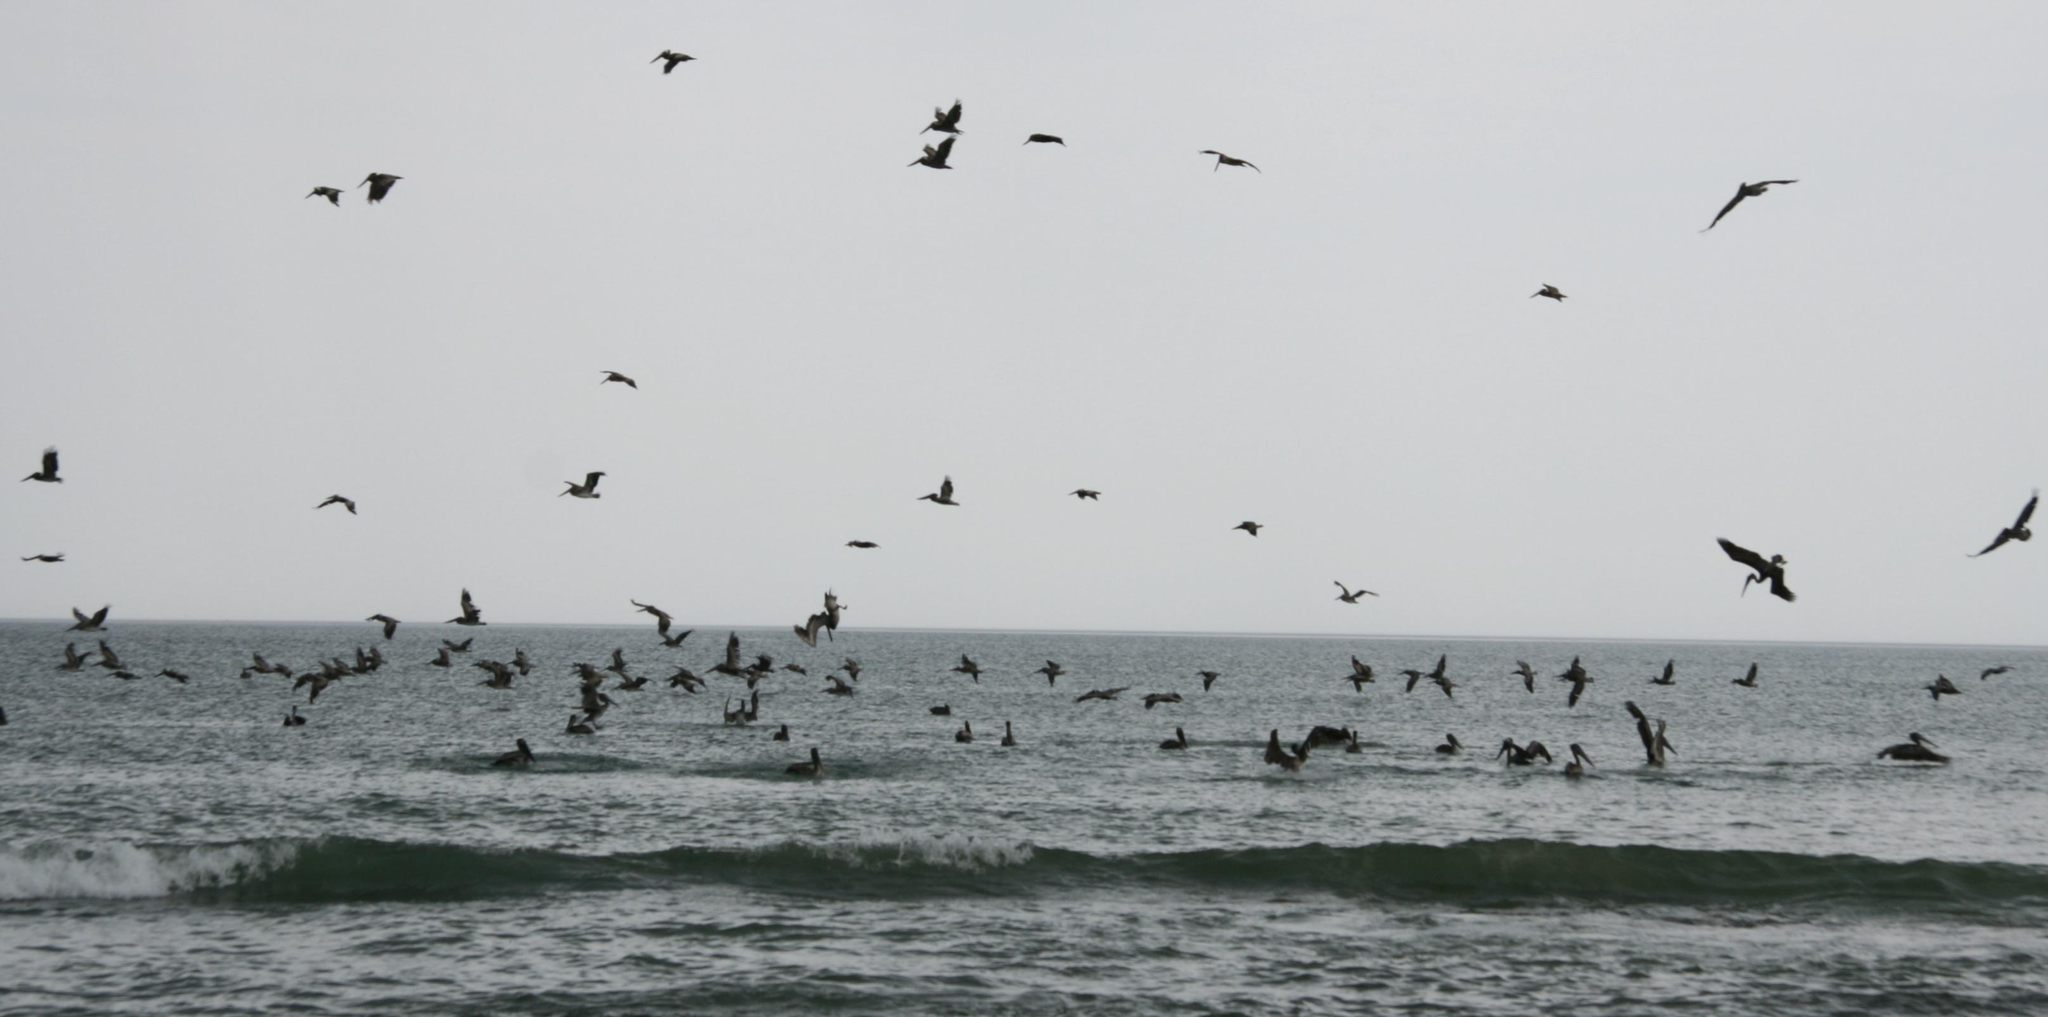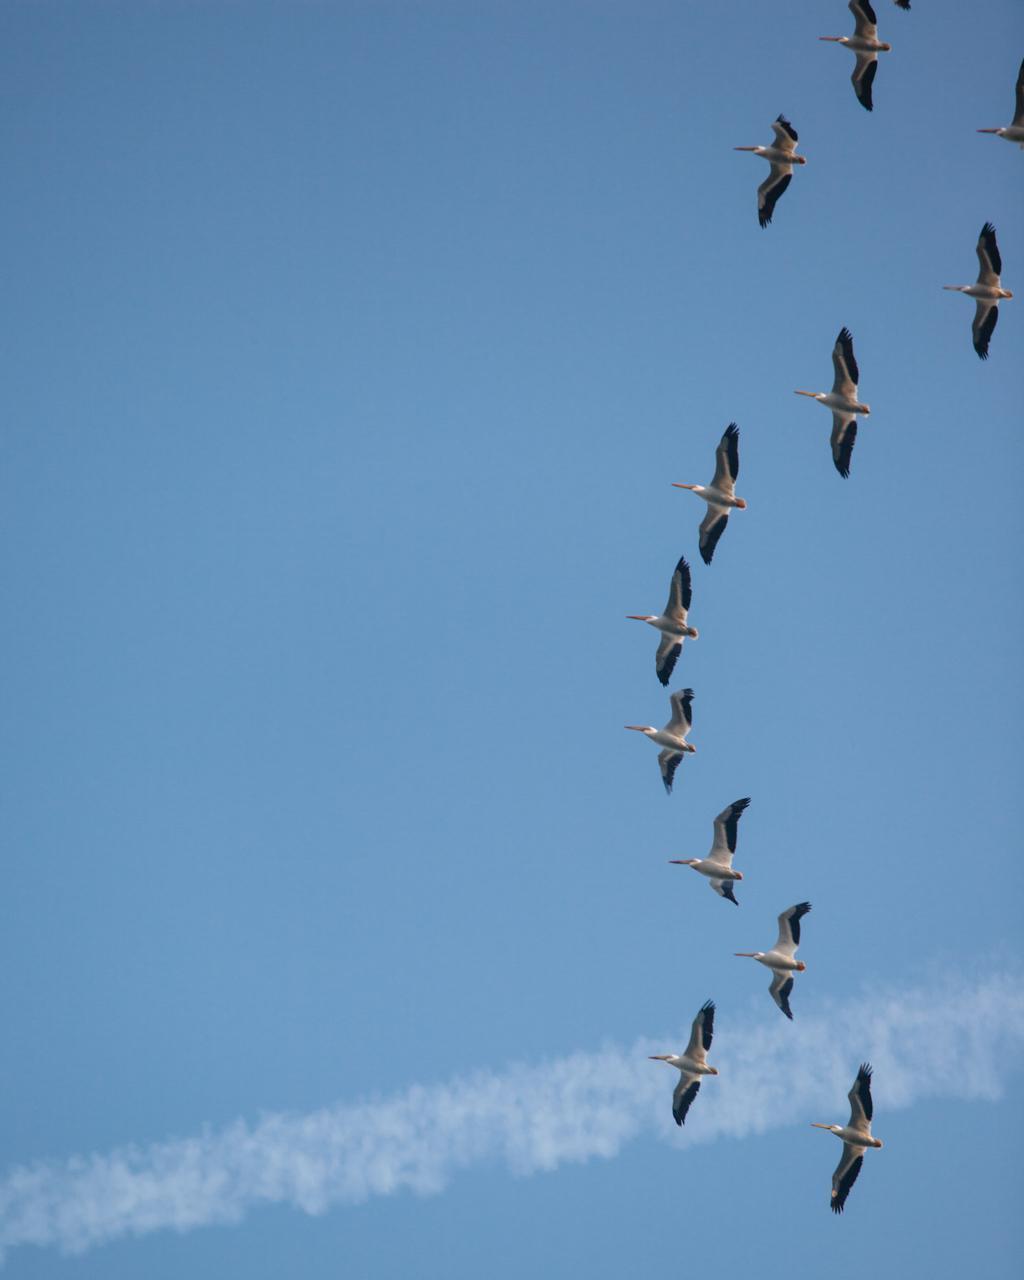The first image is the image on the left, the second image is the image on the right. For the images displayed, is the sentence "In one image there are some birds above the water." factually correct? Answer yes or no. Yes. The first image is the image on the left, the second image is the image on the right. For the images shown, is this caption "The right image contains a wispy cloud and birds flying in formation." true? Answer yes or no. Yes. 